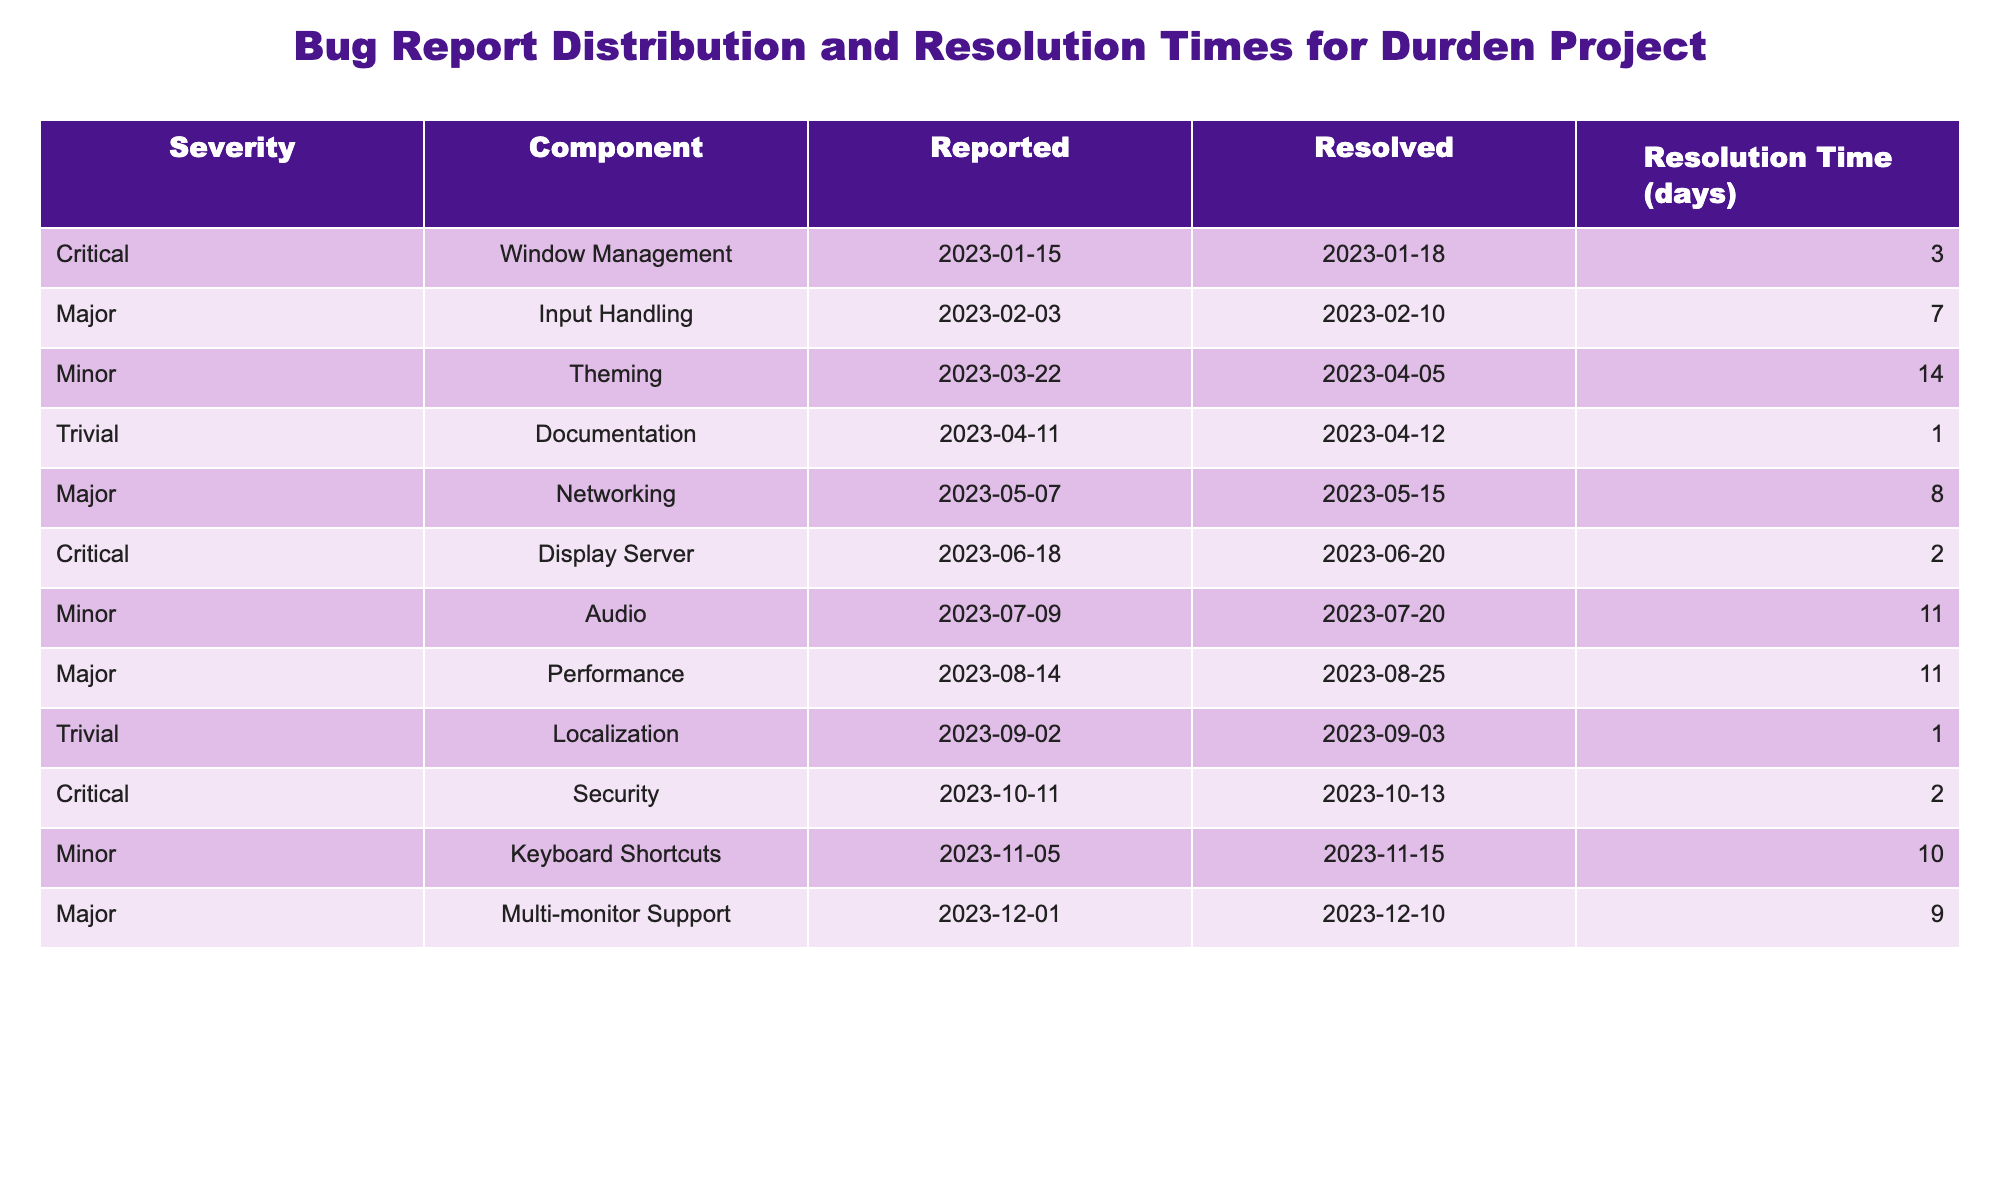What is the total number of bug reports submitted? There are 11 entries in the table, each representing a submitted bug report. Therefore, counting these gives us a total of 11 submitted bug reports.
Answer: 11 Which component had the longest resolution time? The "Theming" component has a resolution time of 14 days, which is the highest compared to other components listed in the table.
Answer: Theming How many bugs were resolved in less than 5 days? The resolved bugs with a resolution time of less than 5 days are as follows: Critical (3 days), Trivial (1 day), Critical (2 days). This gives us a total of 3 bugs resolved in less than 5 days.
Answer: 3 What is the average resolution time for bug reports? The total resolution time for all reports is (3 + 7 + 14 + 1 + 8 + 2 + 11 + 11 + 1 + 2 + 10 + 9) = 88 days. There are 11 reports, so the average resolution time is 88 / 11 = 8 days.
Answer: 8 Were there any bug reports marked as "Trivial" that took more than 5 days to resolve? The only "Trivial" bug reported was related to Documentation, which took only 1 day to resolve. Therefore, there are no "Trivial" reports that took more than 5 days to resolve.
Answer: No Which severity level had the highest number of reports? Counting the severity levels from the table: Critical (3), Major (4), Minor (3), Trivial (2). The Major severity level has the highest number of reports at 4.
Answer: Major What is the total resolution time for all bug reports under the "Minor" severity level? The Minor severity reports are: Audio (11 days), Theming (14 days), and Keyboard Shortcuts (10 days). The total resolution time is 11 + 14 + 10 = 35 days.
Answer: 35 days Is there any component that has only one bug report? By reviewing the table, we see that both Documentation (Trivial) and Localization (Trivial) each only have one bug report listed. Therefore, there are components with only one bug report.
Answer: Yes What is the difference in resolution time between "Major" and "Critical" severity levels? The average resolution time for "Major" is (7 + 8 + 11 + 9) / 4 = 8.75 days, while for "Critical" it’s (3 + 2 + 2) / 3 = 2.33 days. The difference is 8.75 - 2.33 = 6.42 days.
Answer: 6.42 days How many bug reports were submitted each month? The reports were submitted: January (1), February (1), March (1), April (2), May (1), June (1), July (1), August (1), September (1), October (1), November (1), December (1). There were a total of 11 reports, with April being the only month with 2 reports.
Answer: April has 2 reports, others have 1 